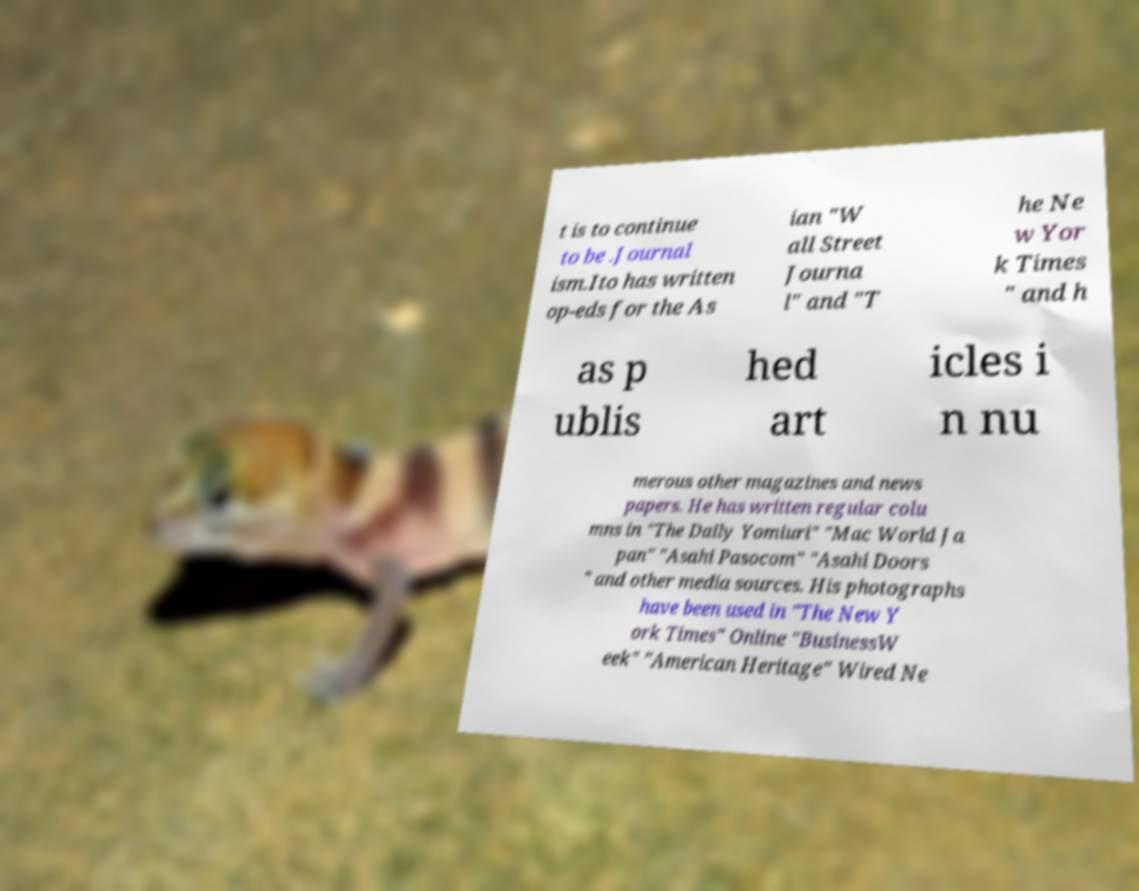Please identify and transcribe the text found in this image. t is to continue to be .Journal ism.Ito has written op-eds for the As ian "W all Street Journa l" and "T he Ne w Yor k Times " and h as p ublis hed art icles i n nu merous other magazines and news papers. He has written regular colu mns in "The Daily Yomiuri" "Mac World Ja pan" "Asahi Pasocom" "Asahi Doors " and other media sources. His photographs have been used in "The New Y ork Times" Online "BusinessW eek" "American Heritage" Wired Ne 